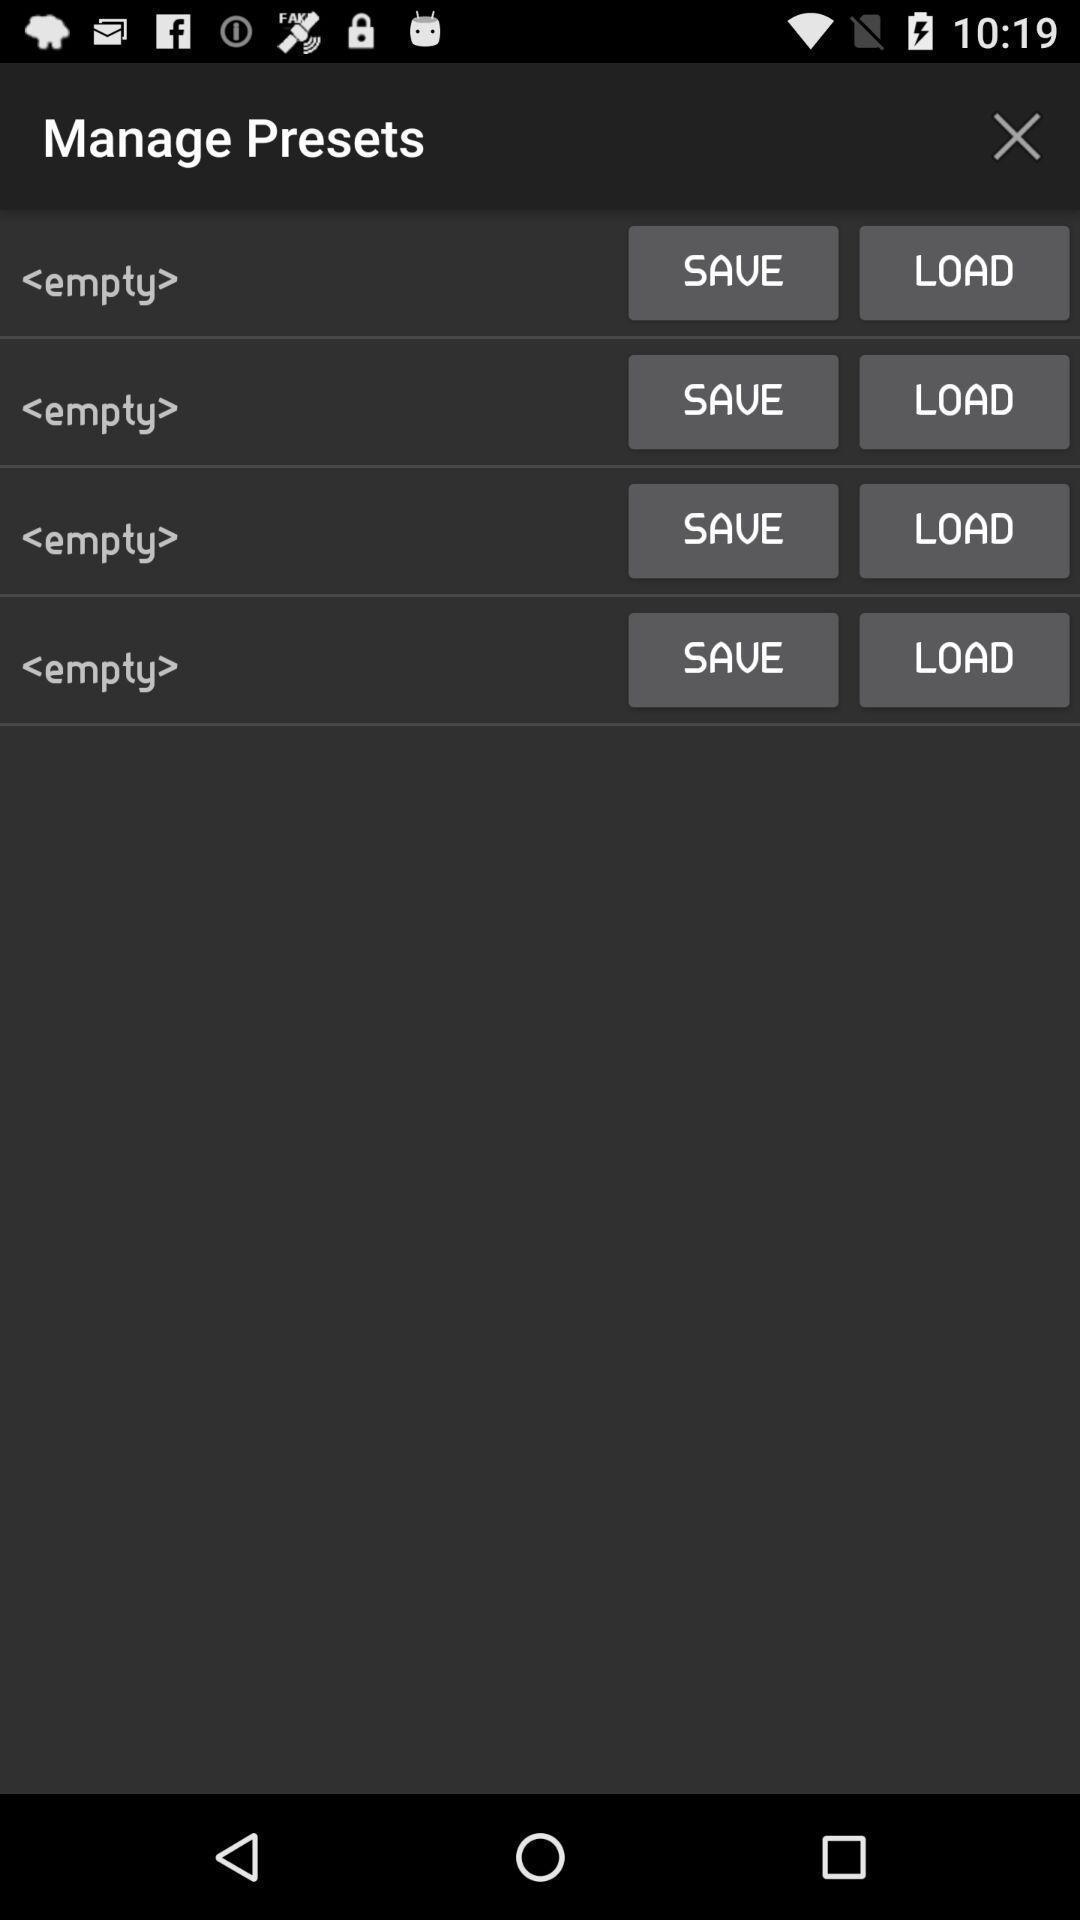Explain what's happening in this screen capture. Page shows manage presets with few other options in application. 